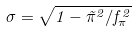<formula> <loc_0><loc_0><loc_500><loc_500>\sigma = \sqrt { 1 - \vec { \pi } ^ { 2 } / f ^ { 2 } _ { \pi } }</formula> 